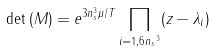<formula> <loc_0><loc_0><loc_500><loc_500>\det { ( M ) } = e ^ { 3 n _ { s } ^ { 3 } \mu / T } \prod _ { i = 1 , 6 { n _ { s } } ^ { 3 } } ( z - \lambda _ { i } )</formula> 